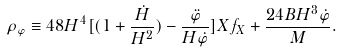<formula> <loc_0><loc_0><loc_500><loc_500>\rho _ { \varphi } \equiv 4 8 H ^ { 4 } [ ( 1 + \frac { \dot { H } } { H ^ { 2 } } ) - \frac { \ddot { \varphi } } { H \dot { \varphi } } ] X f _ { X } + \frac { 2 4 B H ^ { 3 } \dot { \varphi } } { M } .</formula> 